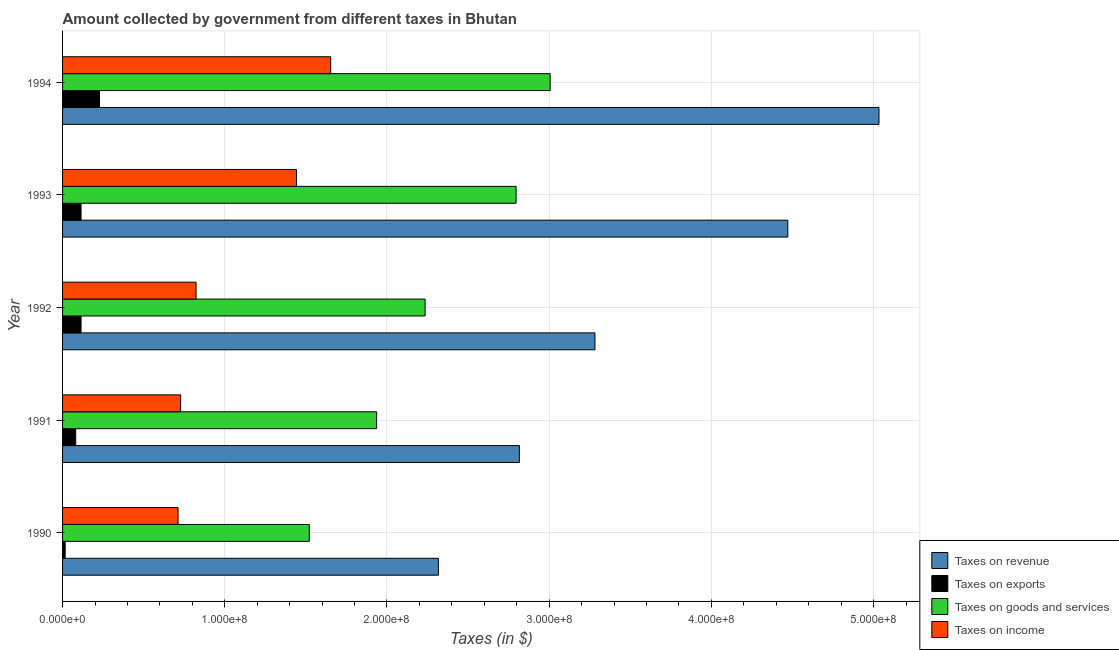How many groups of bars are there?
Provide a short and direct response. 5. Are the number of bars on each tick of the Y-axis equal?
Your answer should be very brief. Yes. What is the amount collected as tax on revenue in 1993?
Your answer should be compact. 4.47e+08. Across all years, what is the maximum amount collected as tax on income?
Offer a very short reply. 1.65e+08. Across all years, what is the minimum amount collected as tax on exports?
Provide a succinct answer. 1.60e+06. In which year was the amount collected as tax on goods maximum?
Your answer should be very brief. 1994. What is the total amount collected as tax on revenue in the graph?
Offer a very short reply. 1.79e+09. What is the difference between the amount collected as tax on income in 1990 and that in 1993?
Your answer should be very brief. -7.30e+07. What is the difference between the amount collected as tax on goods in 1993 and the amount collected as tax on revenue in 1992?
Your response must be concise. -4.86e+07. What is the average amount collected as tax on goods per year?
Offer a very short reply. 2.30e+08. In the year 1990, what is the difference between the amount collected as tax on goods and amount collected as tax on exports?
Offer a very short reply. 1.50e+08. What is the ratio of the amount collected as tax on revenue in 1990 to that in 1992?
Offer a terse response. 0.71. Is the difference between the amount collected as tax on revenue in 1990 and 1992 greater than the difference between the amount collected as tax on goods in 1990 and 1992?
Ensure brevity in your answer.  No. What is the difference between the highest and the second highest amount collected as tax on goods?
Provide a short and direct response. 2.10e+07. What is the difference between the highest and the lowest amount collected as tax on income?
Make the answer very short. 9.41e+07. In how many years, is the amount collected as tax on goods greater than the average amount collected as tax on goods taken over all years?
Your response must be concise. 2. Is the sum of the amount collected as tax on revenue in 1990 and 1993 greater than the maximum amount collected as tax on exports across all years?
Give a very brief answer. Yes. What does the 2nd bar from the top in 1994 represents?
Ensure brevity in your answer.  Taxes on goods and services. What does the 4th bar from the bottom in 1992 represents?
Offer a very short reply. Taxes on income. How many bars are there?
Your response must be concise. 20. How many years are there in the graph?
Provide a short and direct response. 5. Are the values on the major ticks of X-axis written in scientific E-notation?
Ensure brevity in your answer.  Yes. Does the graph contain any zero values?
Make the answer very short. No. Does the graph contain grids?
Give a very brief answer. Yes. How many legend labels are there?
Provide a short and direct response. 4. What is the title of the graph?
Provide a short and direct response. Amount collected by government from different taxes in Bhutan. Does "International Development Association" appear as one of the legend labels in the graph?
Provide a short and direct response. No. What is the label or title of the X-axis?
Provide a succinct answer. Taxes (in $). What is the label or title of the Y-axis?
Give a very brief answer. Year. What is the Taxes (in $) of Taxes on revenue in 1990?
Make the answer very short. 2.32e+08. What is the Taxes (in $) in Taxes on exports in 1990?
Offer a very short reply. 1.60e+06. What is the Taxes (in $) of Taxes on goods and services in 1990?
Keep it short and to the point. 1.52e+08. What is the Taxes (in $) of Taxes on income in 1990?
Make the answer very short. 7.12e+07. What is the Taxes (in $) in Taxes on revenue in 1991?
Provide a succinct answer. 2.82e+08. What is the Taxes (in $) in Taxes on exports in 1991?
Provide a succinct answer. 8.10e+06. What is the Taxes (in $) in Taxes on goods and services in 1991?
Your answer should be compact. 1.94e+08. What is the Taxes (in $) in Taxes on income in 1991?
Give a very brief answer. 7.28e+07. What is the Taxes (in $) of Taxes on revenue in 1992?
Make the answer very short. 3.28e+08. What is the Taxes (in $) in Taxes on exports in 1992?
Provide a short and direct response. 1.14e+07. What is the Taxes (in $) in Taxes on goods and services in 1992?
Provide a short and direct response. 2.24e+08. What is the Taxes (in $) in Taxes on income in 1992?
Offer a very short reply. 8.23e+07. What is the Taxes (in $) of Taxes on revenue in 1993?
Provide a succinct answer. 4.47e+08. What is the Taxes (in $) in Taxes on exports in 1993?
Make the answer very short. 1.14e+07. What is the Taxes (in $) of Taxes on goods and services in 1993?
Keep it short and to the point. 2.80e+08. What is the Taxes (in $) of Taxes on income in 1993?
Your answer should be very brief. 1.44e+08. What is the Taxes (in $) in Taxes on revenue in 1994?
Offer a very short reply. 5.03e+08. What is the Taxes (in $) of Taxes on exports in 1994?
Your response must be concise. 2.28e+07. What is the Taxes (in $) in Taxes on goods and services in 1994?
Make the answer very short. 3.01e+08. What is the Taxes (in $) of Taxes on income in 1994?
Offer a terse response. 1.65e+08. Across all years, what is the maximum Taxes (in $) of Taxes on revenue?
Make the answer very short. 5.03e+08. Across all years, what is the maximum Taxes (in $) in Taxes on exports?
Your answer should be very brief. 2.28e+07. Across all years, what is the maximum Taxes (in $) of Taxes on goods and services?
Your answer should be compact. 3.01e+08. Across all years, what is the maximum Taxes (in $) of Taxes on income?
Provide a succinct answer. 1.65e+08. Across all years, what is the minimum Taxes (in $) in Taxes on revenue?
Make the answer very short. 2.32e+08. Across all years, what is the minimum Taxes (in $) of Taxes on exports?
Your answer should be very brief. 1.60e+06. Across all years, what is the minimum Taxes (in $) of Taxes on goods and services?
Offer a very short reply. 1.52e+08. Across all years, what is the minimum Taxes (in $) of Taxes on income?
Offer a very short reply. 7.12e+07. What is the total Taxes (in $) in Taxes on revenue in the graph?
Give a very brief answer. 1.79e+09. What is the total Taxes (in $) in Taxes on exports in the graph?
Offer a very short reply. 5.53e+07. What is the total Taxes (in $) of Taxes on goods and services in the graph?
Your response must be concise. 1.15e+09. What is the total Taxes (in $) of Taxes on income in the graph?
Keep it short and to the point. 5.36e+08. What is the difference between the Taxes (in $) in Taxes on revenue in 1990 and that in 1991?
Give a very brief answer. -4.99e+07. What is the difference between the Taxes (in $) of Taxes on exports in 1990 and that in 1991?
Provide a succinct answer. -6.50e+06. What is the difference between the Taxes (in $) of Taxes on goods and services in 1990 and that in 1991?
Offer a terse response. -4.15e+07. What is the difference between the Taxes (in $) of Taxes on income in 1990 and that in 1991?
Offer a terse response. -1.60e+06. What is the difference between the Taxes (in $) of Taxes on revenue in 1990 and that in 1992?
Ensure brevity in your answer.  -9.65e+07. What is the difference between the Taxes (in $) of Taxes on exports in 1990 and that in 1992?
Provide a succinct answer. -9.80e+06. What is the difference between the Taxes (in $) in Taxes on goods and services in 1990 and that in 1992?
Ensure brevity in your answer.  -7.14e+07. What is the difference between the Taxes (in $) in Taxes on income in 1990 and that in 1992?
Offer a very short reply. -1.11e+07. What is the difference between the Taxes (in $) in Taxes on revenue in 1990 and that in 1993?
Make the answer very short. -2.15e+08. What is the difference between the Taxes (in $) in Taxes on exports in 1990 and that in 1993?
Offer a terse response. -9.80e+06. What is the difference between the Taxes (in $) in Taxes on goods and services in 1990 and that in 1993?
Your answer should be very brief. -1.28e+08. What is the difference between the Taxes (in $) of Taxes on income in 1990 and that in 1993?
Your answer should be very brief. -7.30e+07. What is the difference between the Taxes (in $) in Taxes on revenue in 1990 and that in 1994?
Your response must be concise. -2.72e+08. What is the difference between the Taxes (in $) in Taxes on exports in 1990 and that in 1994?
Your answer should be compact. -2.12e+07. What is the difference between the Taxes (in $) of Taxes on goods and services in 1990 and that in 1994?
Your answer should be compact. -1.48e+08. What is the difference between the Taxes (in $) in Taxes on income in 1990 and that in 1994?
Make the answer very short. -9.41e+07. What is the difference between the Taxes (in $) of Taxes on revenue in 1991 and that in 1992?
Keep it short and to the point. -4.66e+07. What is the difference between the Taxes (in $) in Taxes on exports in 1991 and that in 1992?
Ensure brevity in your answer.  -3.30e+06. What is the difference between the Taxes (in $) in Taxes on goods and services in 1991 and that in 1992?
Provide a short and direct response. -2.99e+07. What is the difference between the Taxes (in $) in Taxes on income in 1991 and that in 1992?
Your answer should be very brief. -9.50e+06. What is the difference between the Taxes (in $) of Taxes on revenue in 1991 and that in 1993?
Ensure brevity in your answer.  -1.66e+08. What is the difference between the Taxes (in $) of Taxes on exports in 1991 and that in 1993?
Offer a terse response. -3.30e+06. What is the difference between the Taxes (in $) of Taxes on goods and services in 1991 and that in 1993?
Offer a very short reply. -8.60e+07. What is the difference between the Taxes (in $) of Taxes on income in 1991 and that in 1993?
Provide a short and direct response. -7.14e+07. What is the difference between the Taxes (in $) of Taxes on revenue in 1991 and that in 1994?
Provide a short and direct response. -2.22e+08. What is the difference between the Taxes (in $) of Taxes on exports in 1991 and that in 1994?
Your answer should be compact. -1.47e+07. What is the difference between the Taxes (in $) of Taxes on goods and services in 1991 and that in 1994?
Your answer should be very brief. -1.07e+08. What is the difference between the Taxes (in $) of Taxes on income in 1991 and that in 1994?
Your answer should be compact. -9.25e+07. What is the difference between the Taxes (in $) in Taxes on revenue in 1992 and that in 1993?
Provide a succinct answer. -1.19e+08. What is the difference between the Taxes (in $) of Taxes on exports in 1992 and that in 1993?
Your answer should be compact. 0. What is the difference between the Taxes (in $) of Taxes on goods and services in 1992 and that in 1993?
Ensure brevity in your answer.  -5.61e+07. What is the difference between the Taxes (in $) in Taxes on income in 1992 and that in 1993?
Make the answer very short. -6.19e+07. What is the difference between the Taxes (in $) of Taxes on revenue in 1992 and that in 1994?
Offer a terse response. -1.75e+08. What is the difference between the Taxes (in $) of Taxes on exports in 1992 and that in 1994?
Ensure brevity in your answer.  -1.14e+07. What is the difference between the Taxes (in $) of Taxes on goods and services in 1992 and that in 1994?
Give a very brief answer. -7.71e+07. What is the difference between the Taxes (in $) in Taxes on income in 1992 and that in 1994?
Ensure brevity in your answer.  -8.30e+07. What is the difference between the Taxes (in $) of Taxes on revenue in 1993 and that in 1994?
Ensure brevity in your answer.  -5.62e+07. What is the difference between the Taxes (in $) of Taxes on exports in 1993 and that in 1994?
Offer a terse response. -1.14e+07. What is the difference between the Taxes (in $) of Taxes on goods and services in 1993 and that in 1994?
Give a very brief answer. -2.10e+07. What is the difference between the Taxes (in $) in Taxes on income in 1993 and that in 1994?
Give a very brief answer. -2.11e+07. What is the difference between the Taxes (in $) of Taxes on revenue in 1990 and the Taxes (in $) of Taxes on exports in 1991?
Ensure brevity in your answer.  2.24e+08. What is the difference between the Taxes (in $) of Taxes on revenue in 1990 and the Taxes (in $) of Taxes on goods and services in 1991?
Your response must be concise. 3.81e+07. What is the difference between the Taxes (in $) of Taxes on revenue in 1990 and the Taxes (in $) of Taxes on income in 1991?
Ensure brevity in your answer.  1.59e+08. What is the difference between the Taxes (in $) in Taxes on exports in 1990 and the Taxes (in $) in Taxes on goods and services in 1991?
Provide a short and direct response. -1.92e+08. What is the difference between the Taxes (in $) of Taxes on exports in 1990 and the Taxes (in $) of Taxes on income in 1991?
Your response must be concise. -7.12e+07. What is the difference between the Taxes (in $) in Taxes on goods and services in 1990 and the Taxes (in $) in Taxes on income in 1991?
Your answer should be compact. 7.93e+07. What is the difference between the Taxes (in $) of Taxes on revenue in 1990 and the Taxes (in $) of Taxes on exports in 1992?
Ensure brevity in your answer.  2.20e+08. What is the difference between the Taxes (in $) in Taxes on revenue in 1990 and the Taxes (in $) in Taxes on goods and services in 1992?
Offer a terse response. 8.20e+06. What is the difference between the Taxes (in $) in Taxes on revenue in 1990 and the Taxes (in $) in Taxes on income in 1992?
Your answer should be very brief. 1.49e+08. What is the difference between the Taxes (in $) in Taxes on exports in 1990 and the Taxes (in $) in Taxes on goods and services in 1992?
Provide a short and direct response. -2.22e+08. What is the difference between the Taxes (in $) of Taxes on exports in 1990 and the Taxes (in $) of Taxes on income in 1992?
Offer a terse response. -8.07e+07. What is the difference between the Taxes (in $) of Taxes on goods and services in 1990 and the Taxes (in $) of Taxes on income in 1992?
Offer a terse response. 6.98e+07. What is the difference between the Taxes (in $) in Taxes on revenue in 1990 and the Taxes (in $) in Taxes on exports in 1993?
Offer a very short reply. 2.20e+08. What is the difference between the Taxes (in $) in Taxes on revenue in 1990 and the Taxes (in $) in Taxes on goods and services in 1993?
Keep it short and to the point. -4.79e+07. What is the difference between the Taxes (in $) of Taxes on revenue in 1990 and the Taxes (in $) of Taxes on income in 1993?
Your answer should be compact. 8.75e+07. What is the difference between the Taxes (in $) of Taxes on exports in 1990 and the Taxes (in $) of Taxes on goods and services in 1993?
Keep it short and to the point. -2.78e+08. What is the difference between the Taxes (in $) in Taxes on exports in 1990 and the Taxes (in $) in Taxes on income in 1993?
Offer a terse response. -1.43e+08. What is the difference between the Taxes (in $) of Taxes on goods and services in 1990 and the Taxes (in $) of Taxes on income in 1993?
Provide a short and direct response. 7.90e+06. What is the difference between the Taxes (in $) of Taxes on revenue in 1990 and the Taxes (in $) of Taxes on exports in 1994?
Your answer should be very brief. 2.09e+08. What is the difference between the Taxes (in $) of Taxes on revenue in 1990 and the Taxes (in $) of Taxes on goods and services in 1994?
Ensure brevity in your answer.  -6.89e+07. What is the difference between the Taxes (in $) of Taxes on revenue in 1990 and the Taxes (in $) of Taxes on income in 1994?
Ensure brevity in your answer.  6.64e+07. What is the difference between the Taxes (in $) of Taxes on exports in 1990 and the Taxes (in $) of Taxes on goods and services in 1994?
Ensure brevity in your answer.  -2.99e+08. What is the difference between the Taxes (in $) of Taxes on exports in 1990 and the Taxes (in $) of Taxes on income in 1994?
Your response must be concise. -1.64e+08. What is the difference between the Taxes (in $) in Taxes on goods and services in 1990 and the Taxes (in $) in Taxes on income in 1994?
Provide a succinct answer. -1.32e+07. What is the difference between the Taxes (in $) of Taxes on revenue in 1991 and the Taxes (in $) of Taxes on exports in 1992?
Your response must be concise. 2.70e+08. What is the difference between the Taxes (in $) in Taxes on revenue in 1991 and the Taxes (in $) in Taxes on goods and services in 1992?
Offer a very short reply. 5.81e+07. What is the difference between the Taxes (in $) in Taxes on revenue in 1991 and the Taxes (in $) in Taxes on income in 1992?
Provide a short and direct response. 1.99e+08. What is the difference between the Taxes (in $) in Taxes on exports in 1991 and the Taxes (in $) in Taxes on goods and services in 1992?
Offer a very short reply. -2.15e+08. What is the difference between the Taxes (in $) of Taxes on exports in 1991 and the Taxes (in $) of Taxes on income in 1992?
Offer a terse response. -7.42e+07. What is the difference between the Taxes (in $) in Taxes on goods and services in 1991 and the Taxes (in $) in Taxes on income in 1992?
Your response must be concise. 1.11e+08. What is the difference between the Taxes (in $) in Taxes on revenue in 1991 and the Taxes (in $) in Taxes on exports in 1993?
Provide a succinct answer. 2.70e+08. What is the difference between the Taxes (in $) of Taxes on revenue in 1991 and the Taxes (in $) of Taxes on income in 1993?
Offer a very short reply. 1.37e+08. What is the difference between the Taxes (in $) in Taxes on exports in 1991 and the Taxes (in $) in Taxes on goods and services in 1993?
Offer a very short reply. -2.72e+08. What is the difference between the Taxes (in $) in Taxes on exports in 1991 and the Taxes (in $) in Taxes on income in 1993?
Offer a very short reply. -1.36e+08. What is the difference between the Taxes (in $) of Taxes on goods and services in 1991 and the Taxes (in $) of Taxes on income in 1993?
Your answer should be compact. 4.94e+07. What is the difference between the Taxes (in $) of Taxes on revenue in 1991 and the Taxes (in $) of Taxes on exports in 1994?
Give a very brief answer. 2.59e+08. What is the difference between the Taxes (in $) in Taxes on revenue in 1991 and the Taxes (in $) in Taxes on goods and services in 1994?
Your answer should be very brief. -1.90e+07. What is the difference between the Taxes (in $) in Taxes on revenue in 1991 and the Taxes (in $) in Taxes on income in 1994?
Your answer should be very brief. 1.16e+08. What is the difference between the Taxes (in $) in Taxes on exports in 1991 and the Taxes (in $) in Taxes on goods and services in 1994?
Your answer should be very brief. -2.92e+08. What is the difference between the Taxes (in $) in Taxes on exports in 1991 and the Taxes (in $) in Taxes on income in 1994?
Keep it short and to the point. -1.57e+08. What is the difference between the Taxes (in $) of Taxes on goods and services in 1991 and the Taxes (in $) of Taxes on income in 1994?
Offer a terse response. 2.83e+07. What is the difference between the Taxes (in $) in Taxes on revenue in 1992 and the Taxes (in $) in Taxes on exports in 1993?
Provide a succinct answer. 3.17e+08. What is the difference between the Taxes (in $) of Taxes on revenue in 1992 and the Taxes (in $) of Taxes on goods and services in 1993?
Offer a terse response. 4.86e+07. What is the difference between the Taxes (in $) in Taxes on revenue in 1992 and the Taxes (in $) in Taxes on income in 1993?
Your response must be concise. 1.84e+08. What is the difference between the Taxes (in $) of Taxes on exports in 1992 and the Taxes (in $) of Taxes on goods and services in 1993?
Offer a terse response. -2.68e+08. What is the difference between the Taxes (in $) in Taxes on exports in 1992 and the Taxes (in $) in Taxes on income in 1993?
Give a very brief answer. -1.33e+08. What is the difference between the Taxes (in $) of Taxes on goods and services in 1992 and the Taxes (in $) of Taxes on income in 1993?
Keep it short and to the point. 7.93e+07. What is the difference between the Taxes (in $) in Taxes on revenue in 1992 and the Taxes (in $) in Taxes on exports in 1994?
Offer a very short reply. 3.05e+08. What is the difference between the Taxes (in $) in Taxes on revenue in 1992 and the Taxes (in $) in Taxes on goods and services in 1994?
Provide a succinct answer. 2.76e+07. What is the difference between the Taxes (in $) of Taxes on revenue in 1992 and the Taxes (in $) of Taxes on income in 1994?
Your response must be concise. 1.63e+08. What is the difference between the Taxes (in $) of Taxes on exports in 1992 and the Taxes (in $) of Taxes on goods and services in 1994?
Your answer should be compact. -2.89e+08. What is the difference between the Taxes (in $) in Taxes on exports in 1992 and the Taxes (in $) in Taxes on income in 1994?
Your answer should be very brief. -1.54e+08. What is the difference between the Taxes (in $) in Taxes on goods and services in 1992 and the Taxes (in $) in Taxes on income in 1994?
Give a very brief answer. 5.82e+07. What is the difference between the Taxes (in $) of Taxes on revenue in 1993 and the Taxes (in $) of Taxes on exports in 1994?
Offer a very short reply. 4.24e+08. What is the difference between the Taxes (in $) in Taxes on revenue in 1993 and the Taxes (in $) in Taxes on goods and services in 1994?
Offer a very short reply. 1.46e+08. What is the difference between the Taxes (in $) of Taxes on revenue in 1993 and the Taxes (in $) of Taxes on income in 1994?
Your answer should be very brief. 2.82e+08. What is the difference between the Taxes (in $) of Taxes on exports in 1993 and the Taxes (in $) of Taxes on goods and services in 1994?
Give a very brief answer. -2.89e+08. What is the difference between the Taxes (in $) in Taxes on exports in 1993 and the Taxes (in $) in Taxes on income in 1994?
Provide a short and direct response. -1.54e+08. What is the difference between the Taxes (in $) of Taxes on goods and services in 1993 and the Taxes (in $) of Taxes on income in 1994?
Offer a very short reply. 1.14e+08. What is the average Taxes (in $) of Taxes on revenue per year?
Provide a short and direct response. 3.58e+08. What is the average Taxes (in $) of Taxes on exports per year?
Make the answer very short. 1.11e+07. What is the average Taxes (in $) in Taxes on goods and services per year?
Give a very brief answer. 2.30e+08. What is the average Taxes (in $) in Taxes on income per year?
Your answer should be compact. 1.07e+08. In the year 1990, what is the difference between the Taxes (in $) in Taxes on revenue and Taxes (in $) in Taxes on exports?
Provide a short and direct response. 2.30e+08. In the year 1990, what is the difference between the Taxes (in $) in Taxes on revenue and Taxes (in $) in Taxes on goods and services?
Give a very brief answer. 7.96e+07. In the year 1990, what is the difference between the Taxes (in $) of Taxes on revenue and Taxes (in $) of Taxes on income?
Make the answer very short. 1.60e+08. In the year 1990, what is the difference between the Taxes (in $) of Taxes on exports and Taxes (in $) of Taxes on goods and services?
Keep it short and to the point. -1.50e+08. In the year 1990, what is the difference between the Taxes (in $) in Taxes on exports and Taxes (in $) in Taxes on income?
Your answer should be compact. -6.96e+07. In the year 1990, what is the difference between the Taxes (in $) of Taxes on goods and services and Taxes (in $) of Taxes on income?
Provide a succinct answer. 8.09e+07. In the year 1991, what is the difference between the Taxes (in $) in Taxes on revenue and Taxes (in $) in Taxes on exports?
Your response must be concise. 2.74e+08. In the year 1991, what is the difference between the Taxes (in $) of Taxes on revenue and Taxes (in $) of Taxes on goods and services?
Your answer should be very brief. 8.80e+07. In the year 1991, what is the difference between the Taxes (in $) in Taxes on revenue and Taxes (in $) in Taxes on income?
Provide a short and direct response. 2.09e+08. In the year 1991, what is the difference between the Taxes (in $) in Taxes on exports and Taxes (in $) in Taxes on goods and services?
Your response must be concise. -1.86e+08. In the year 1991, what is the difference between the Taxes (in $) in Taxes on exports and Taxes (in $) in Taxes on income?
Offer a terse response. -6.47e+07. In the year 1991, what is the difference between the Taxes (in $) of Taxes on goods and services and Taxes (in $) of Taxes on income?
Ensure brevity in your answer.  1.21e+08. In the year 1992, what is the difference between the Taxes (in $) in Taxes on revenue and Taxes (in $) in Taxes on exports?
Offer a terse response. 3.17e+08. In the year 1992, what is the difference between the Taxes (in $) of Taxes on revenue and Taxes (in $) of Taxes on goods and services?
Your answer should be compact. 1.05e+08. In the year 1992, what is the difference between the Taxes (in $) of Taxes on revenue and Taxes (in $) of Taxes on income?
Provide a short and direct response. 2.46e+08. In the year 1992, what is the difference between the Taxes (in $) of Taxes on exports and Taxes (in $) of Taxes on goods and services?
Keep it short and to the point. -2.12e+08. In the year 1992, what is the difference between the Taxes (in $) in Taxes on exports and Taxes (in $) in Taxes on income?
Your answer should be very brief. -7.09e+07. In the year 1992, what is the difference between the Taxes (in $) of Taxes on goods and services and Taxes (in $) of Taxes on income?
Provide a succinct answer. 1.41e+08. In the year 1993, what is the difference between the Taxes (in $) in Taxes on revenue and Taxes (in $) in Taxes on exports?
Your response must be concise. 4.36e+08. In the year 1993, what is the difference between the Taxes (in $) in Taxes on revenue and Taxes (in $) in Taxes on goods and services?
Give a very brief answer. 1.68e+08. In the year 1993, what is the difference between the Taxes (in $) of Taxes on revenue and Taxes (in $) of Taxes on income?
Provide a short and direct response. 3.03e+08. In the year 1993, what is the difference between the Taxes (in $) of Taxes on exports and Taxes (in $) of Taxes on goods and services?
Ensure brevity in your answer.  -2.68e+08. In the year 1993, what is the difference between the Taxes (in $) of Taxes on exports and Taxes (in $) of Taxes on income?
Provide a succinct answer. -1.33e+08. In the year 1993, what is the difference between the Taxes (in $) of Taxes on goods and services and Taxes (in $) of Taxes on income?
Offer a terse response. 1.35e+08. In the year 1994, what is the difference between the Taxes (in $) in Taxes on revenue and Taxes (in $) in Taxes on exports?
Keep it short and to the point. 4.80e+08. In the year 1994, what is the difference between the Taxes (in $) of Taxes on revenue and Taxes (in $) of Taxes on goods and services?
Your answer should be very brief. 2.03e+08. In the year 1994, what is the difference between the Taxes (in $) of Taxes on revenue and Taxes (in $) of Taxes on income?
Provide a short and direct response. 3.38e+08. In the year 1994, what is the difference between the Taxes (in $) of Taxes on exports and Taxes (in $) of Taxes on goods and services?
Ensure brevity in your answer.  -2.78e+08. In the year 1994, what is the difference between the Taxes (in $) in Taxes on exports and Taxes (in $) in Taxes on income?
Your answer should be very brief. -1.42e+08. In the year 1994, what is the difference between the Taxes (in $) of Taxes on goods and services and Taxes (in $) of Taxes on income?
Provide a short and direct response. 1.35e+08. What is the ratio of the Taxes (in $) of Taxes on revenue in 1990 to that in 1991?
Your response must be concise. 0.82. What is the ratio of the Taxes (in $) in Taxes on exports in 1990 to that in 1991?
Your answer should be very brief. 0.2. What is the ratio of the Taxes (in $) in Taxes on goods and services in 1990 to that in 1991?
Provide a succinct answer. 0.79. What is the ratio of the Taxes (in $) of Taxes on income in 1990 to that in 1991?
Your response must be concise. 0.98. What is the ratio of the Taxes (in $) in Taxes on revenue in 1990 to that in 1992?
Your answer should be very brief. 0.71. What is the ratio of the Taxes (in $) in Taxes on exports in 1990 to that in 1992?
Give a very brief answer. 0.14. What is the ratio of the Taxes (in $) of Taxes on goods and services in 1990 to that in 1992?
Offer a very short reply. 0.68. What is the ratio of the Taxes (in $) of Taxes on income in 1990 to that in 1992?
Make the answer very short. 0.87. What is the ratio of the Taxes (in $) in Taxes on revenue in 1990 to that in 1993?
Offer a very short reply. 0.52. What is the ratio of the Taxes (in $) of Taxes on exports in 1990 to that in 1993?
Provide a succinct answer. 0.14. What is the ratio of the Taxes (in $) in Taxes on goods and services in 1990 to that in 1993?
Ensure brevity in your answer.  0.54. What is the ratio of the Taxes (in $) in Taxes on income in 1990 to that in 1993?
Your answer should be very brief. 0.49. What is the ratio of the Taxes (in $) of Taxes on revenue in 1990 to that in 1994?
Make the answer very short. 0.46. What is the ratio of the Taxes (in $) of Taxes on exports in 1990 to that in 1994?
Offer a very short reply. 0.07. What is the ratio of the Taxes (in $) of Taxes on goods and services in 1990 to that in 1994?
Your answer should be very brief. 0.51. What is the ratio of the Taxes (in $) of Taxes on income in 1990 to that in 1994?
Your answer should be compact. 0.43. What is the ratio of the Taxes (in $) of Taxes on revenue in 1991 to that in 1992?
Offer a terse response. 0.86. What is the ratio of the Taxes (in $) in Taxes on exports in 1991 to that in 1992?
Your response must be concise. 0.71. What is the ratio of the Taxes (in $) in Taxes on goods and services in 1991 to that in 1992?
Keep it short and to the point. 0.87. What is the ratio of the Taxes (in $) of Taxes on income in 1991 to that in 1992?
Offer a terse response. 0.88. What is the ratio of the Taxes (in $) in Taxes on revenue in 1991 to that in 1993?
Provide a short and direct response. 0.63. What is the ratio of the Taxes (in $) of Taxes on exports in 1991 to that in 1993?
Keep it short and to the point. 0.71. What is the ratio of the Taxes (in $) in Taxes on goods and services in 1991 to that in 1993?
Keep it short and to the point. 0.69. What is the ratio of the Taxes (in $) of Taxes on income in 1991 to that in 1993?
Offer a very short reply. 0.5. What is the ratio of the Taxes (in $) in Taxes on revenue in 1991 to that in 1994?
Provide a succinct answer. 0.56. What is the ratio of the Taxes (in $) of Taxes on exports in 1991 to that in 1994?
Your answer should be compact. 0.36. What is the ratio of the Taxes (in $) of Taxes on goods and services in 1991 to that in 1994?
Offer a terse response. 0.64. What is the ratio of the Taxes (in $) in Taxes on income in 1991 to that in 1994?
Your answer should be very brief. 0.44. What is the ratio of the Taxes (in $) in Taxes on revenue in 1992 to that in 1993?
Your answer should be compact. 0.73. What is the ratio of the Taxes (in $) in Taxes on exports in 1992 to that in 1993?
Provide a short and direct response. 1. What is the ratio of the Taxes (in $) of Taxes on goods and services in 1992 to that in 1993?
Give a very brief answer. 0.8. What is the ratio of the Taxes (in $) in Taxes on income in 1992 to that in 1993?
Offer a terse response. 0.57. What is the ratio of the Taxes (in $) of Taxes on revenue in 1992 to that in 1994?
Make the answer very short. 0.65. What is the ratio of the Taxes (in $) in Taxes on goods and services in 1992 to that in 1994?
Your response must be concise. 0.74. What is the ratio of the Taxes (in $) in Taxes on income in 1992 to that in 1994?
Make the answer very short. 0.5. What is the ratio of the Taxes (in $) of Taxes on revenue in 1993 to that in 1994?
Offer a terse response. 0.89. What is the ratio of the Taxes (in $) of Taxes on exports in 1993 to that in 1994?
Your answer should be very brief. 0.5. What is the ratio of the Taxes (in $) of Taxes on goods and services in 1993 to that in 1994?
Ensure brevity in your answer.  0.93. What is the ratio of the Taxes (in $) of Taxes on income in 1993 to that in 1994?
Your answer should be very brief. 0.87. What is the difference between the highest and the second highest Taxes (in $) in Taxes on revenue?
Keep it short and to the point. 5.62e+07. What is the difference between the highest and the second highest Taxes (in $) in Taxes on exports?
Your answer should be very brief. 1.14e+07. What is the difference between the highest and the second highest Taxes (in $) of Taxes on goods and services?
Your answer should be compact. 2.10e+07. What is the difference between the highest and the second highest Taxes (in $) in Taxes on income?
Give a very brief answer. 2.11e+07. What is the difference between the highest and the lowest Taxes (in $) of Taxes on revenue?
Keep it short and to the point. 2.72e+08. What is the difference between the highest and the lowest Taxes (in $) in Taxes on exports?
Provide a short and direct response. 2.12e+07. What is the difference between the highest and the lowest Taxes (in $) in Taxes on goods and services?
Your answer should be very brief. 1.48e+08. What is the difference between the highest and the lowest Taxes (in $) of Taxes on income?
Provide a short and direct response. 9.41e+07. 